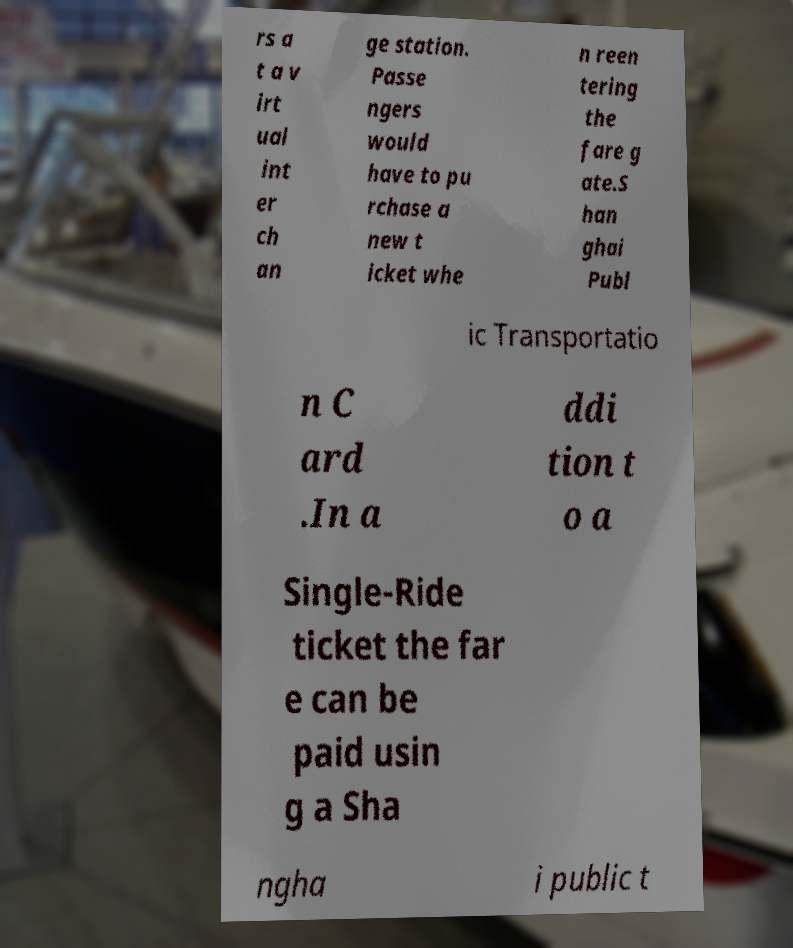Can you accurately transcribe the text from the provided image for me? rs a t a v irt ual int er ch an ge station. Passe ngers would have to pu rchase a new t icket whe n reen tering the fare g ate.S han ghai Publ ic Transportatio n C ard .In a ddi tion t o a Single-Ride ticket the far e can be paid usin g a Sha ngha i public t 